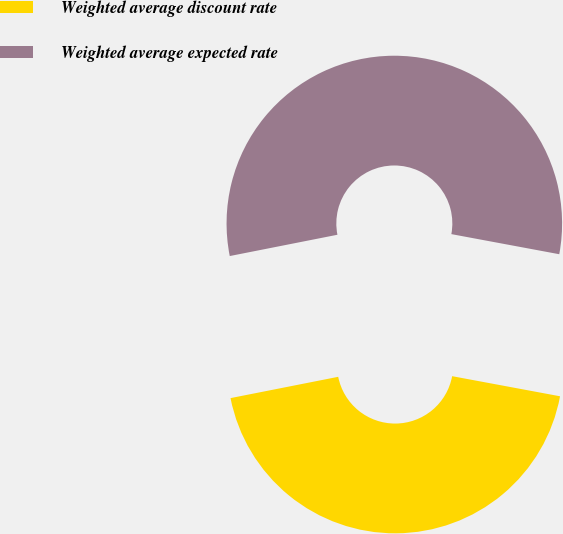Convert chart to OTSL. <chart><loc_0><loc_0><loc_500><loc_500><pie_chart><fcel>Weighted average discount rate<fcel>Weighted average expected rate<nl><fcel>43.96%<fcel>56.04%<nl></chart> 